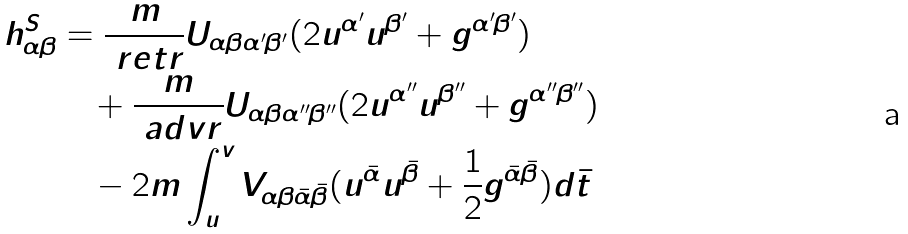Convert formula to latex. <formula><loc_0><loc_0><loc_500><loc_500>h ^ { S } _ { \alpha \beta } & = \frac { m } { \ r e t r } U _ { \alpha \beta \alpha ^ { \prime } \beta ^ { \prime } } ( 2 u ^ { \alpha ^ { \prime } } u ^ { \beta ^ { \prime } } + g ^ { \alpha ^ { \prime } \beta ^ { \prime } } ) \\ & \quad + \frac { m } { \ a d v r } U _ { \alpha \beta \alpha ^ { \prime \prime } \beta ^ { \prime \prime } } ( 2 u ^ { \alpha ^ { \prime \prime } } u ^ { \beta ^ { \prime \prime } } + g ^ { \alpha ^ { \prime \prime } \beta ^ { \prime \prime } } ) \\ & \quad - 2 m \int ^ { v } _ { u } V _ { \alpha \beta \bar { \alpha } \bar { \beta } } ( u ^ { \bar { \alpha } } u ^ { \bar { \beta } } + \frac { 1 } { 2 } g ^ { \bar { \alpha } \bar { \beta } } ) d \bar { t }</formula> 